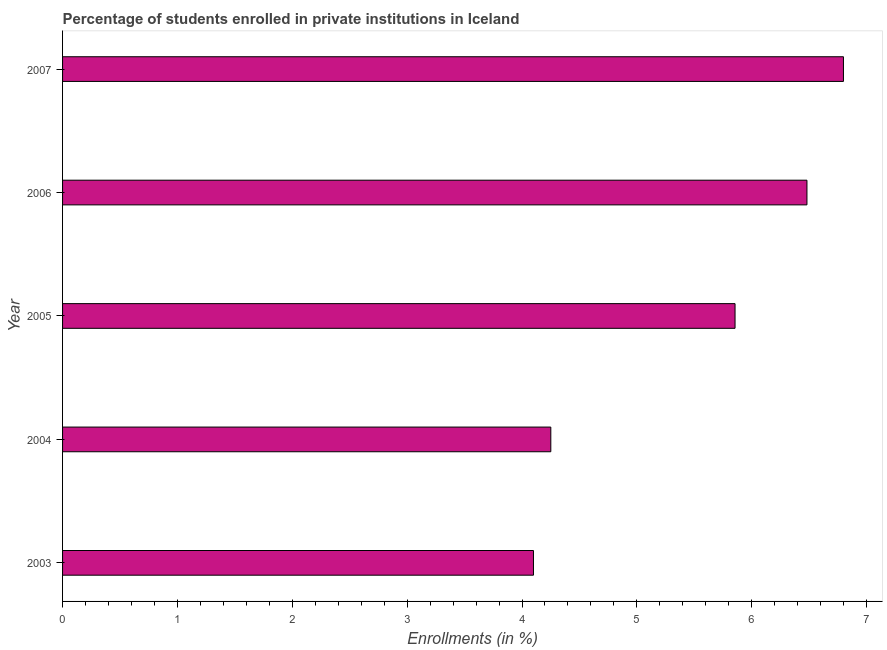What is the title of the graph?
Provide a short and direct response. Percentage of students enrolled in private institutions in Iceland. What is the label or title of the X-axis?
Keep it short and to the point. Enrollments (in %). What is the enrollments in private institutions in 2005?
Keep it short and to the point. 5.85. Across all years, what is the maximum enrollments in private institutions?
Your answer should be compact. 6.8. Across all years, what is the minimum enrollments in private institutions?
Your answer should be very brief. 4.1. In which year was the enrollments in private institutions maximum?
Keep it short and to the point. 2007. In which year was the enrollments in private institutions minimum?
Offer a terse response. 2003. What is the sum of the enrollments in private institutions?
Provide a succinct answer. 27.48. What is the difference between the enrollments in private institutions in 2003 and 2004?
Offer a very short reply. -0.15. What is the average enrollments in private institutions per year?
Keep it short and to the point. 5.5. What is the median enrollments in private institutions?
Ensure brevity in your answer.  5.85. What is the ratio of the enrollments in private institutions in 2004 to that in 2005?
Your answer should be compact. 0.73. What is the difference between the highest and the second highest enrollments in private institutions?
Make the answer very short. 0.32. Is the sum of the enrollments in private institutions in 2005 and 2007 greater than the maximum enrollments in private institutions across all years?
Your response must be concise. Yes. What is the difference between the highest and the lowest enrollments in private institutions?
Make the answer very short. 2.7. In how many years, is the enrollments in private institutions greater than the average enrollments in private institutions taken over all years?
Provide a succinct answer. 3. What is the Enrollments (in %) of 2003?
Give a very brief answer. 4.1. What is the Enrollments (in %) in 2004?
Offer a terse response. 4.25. What is the Enrollments (in %) in 2005?
Keep it short and to the point. 5.85. What is the Enrollments (in %) of 2006?
Your answer should be very brief. 6.48. What is the Enrollments (in %) in 2007?
Give a very brief answer. 6.8. What is the difference between the Enrollments (in %) in 2003 and 2004?
Give a very brief answer. -0.15. What is the difference between the Enrollments (in %) in 2003 and 2005?
Make the answer very short. -1.75. What is the difference between the Enrollments (in %) in 2003 and 2006?
Keep it short and to the point. -2.38. What is the difference between the Enrollments (in %) in 2003 and 2007?
Your answer should be compact. -2.7. What is the difference between the Enrollments (in %) in 2004 and 2005?
Ensure brevity in your answer.  -1.6. What is the difference between the Enrollments (in %) in 2004 and 2006?
Make the answer very short. -2.23. What is the difference between the Enrollments (in %) in 2004 and 2007?
Ensure brevity in your answer.  -2.55. What is the difference between the Enrollments (in %) in 2005 and 2006?
Keep it short and to the point. -0.63. What is the difference between the Enrollments (in %) in 2005 and 2007?
Make the answer very short. -0.94. What is the difference between the Enrollments (in %) in 2006 and 2007?
Ensure brevity in your answer.  -0.32. What is the ratio of the Enrollments (in %) in 2003 to that in 2005?
Your answer should be compact. 0.7. What is the ratio of the Enrollments (in %) in 2003 to that in 2006?
Your answer should be compact. 0.63. What is the ratio of the Enrollments (in %) in 2003 to that in 2007?
Provide a short and direct response. 0.6. What is the ratio of the Enrollments (in %) in 2004 to that in 2005?
Provide a succinct answer. 0.73. What is the ratio of the Enrollments (in %) in 2004 to that in 2006?
Your answer should be very brief. 0.66. What is the ratio of the Enrollments (in %) in 2004 to that in 2007?
Your answer should be compact. 0.62. What is the ratio of the Enrollments (in %) in 2005 to that in 2006?
Ensure brevity in your answer.  0.9. What is the ratio of the Enrollments (in %) in 2005 to that in 2007?
Provide a short and direct response. 0.86. What is the ratio of the Enrollments (in %) in 2006 to that in 2007?
Offer a terse response. 0.95. 